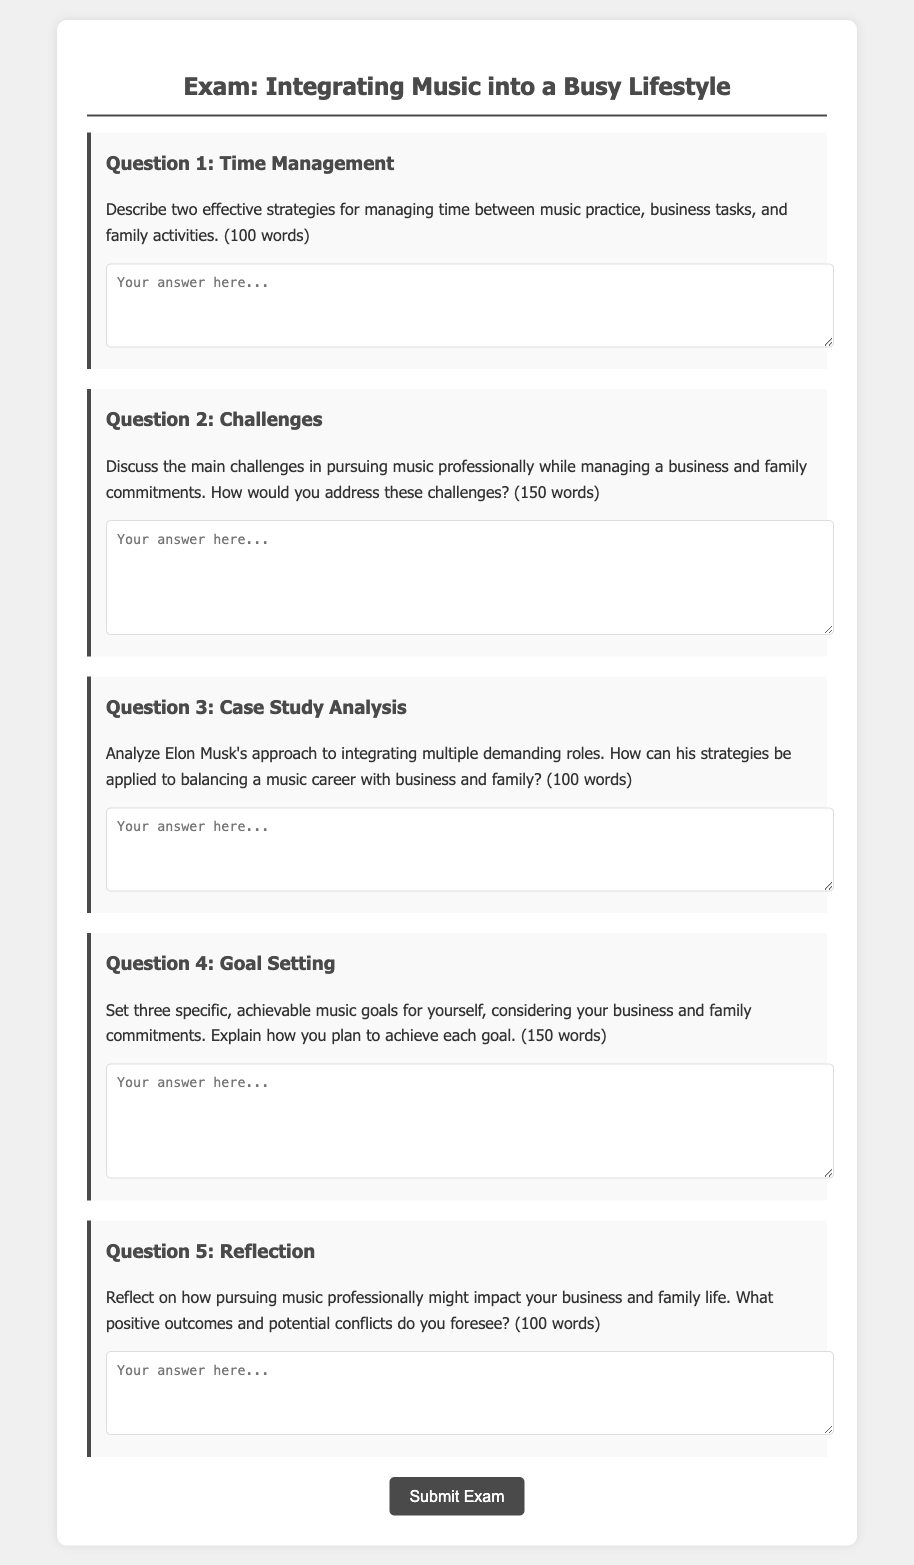What is the title of the exam? The title of the exam is mentioned at the top of the document, which is centered and prominently displayed.
Answer: Integrating Music into a Busy Lifestyle How many questions are included in the exam? The document displays a total of five sections, each containing a question.
Answer: 5 What is the word limit for Question 2? The specific requirement for answering Question 2 is clearly stated in the prompt.
Answer: 150 words What theme does Question 4 focus on? The focus of Question 4 is indicated in its text regarding personal objectives related to a music career.
Answer: Goal Setting Which famous individual's approach is analyzed in Question 3? The question references a well-known entrepreneur to illustrate effective strategies for balancing multiple roles.
Answer: Elon Musk What type of strategies does Question 1 ask about? The question prompts for information on the management of activities within a specific context.
Answer: Effective strategies What color is the background of the exam container? The background color of the main container holding the exam content is described in the document.
Answer: White What action does the button at the end of the document prompt users to take? The button is labeled to initiate the process after completing the exam.
Answer: Submit Exam 